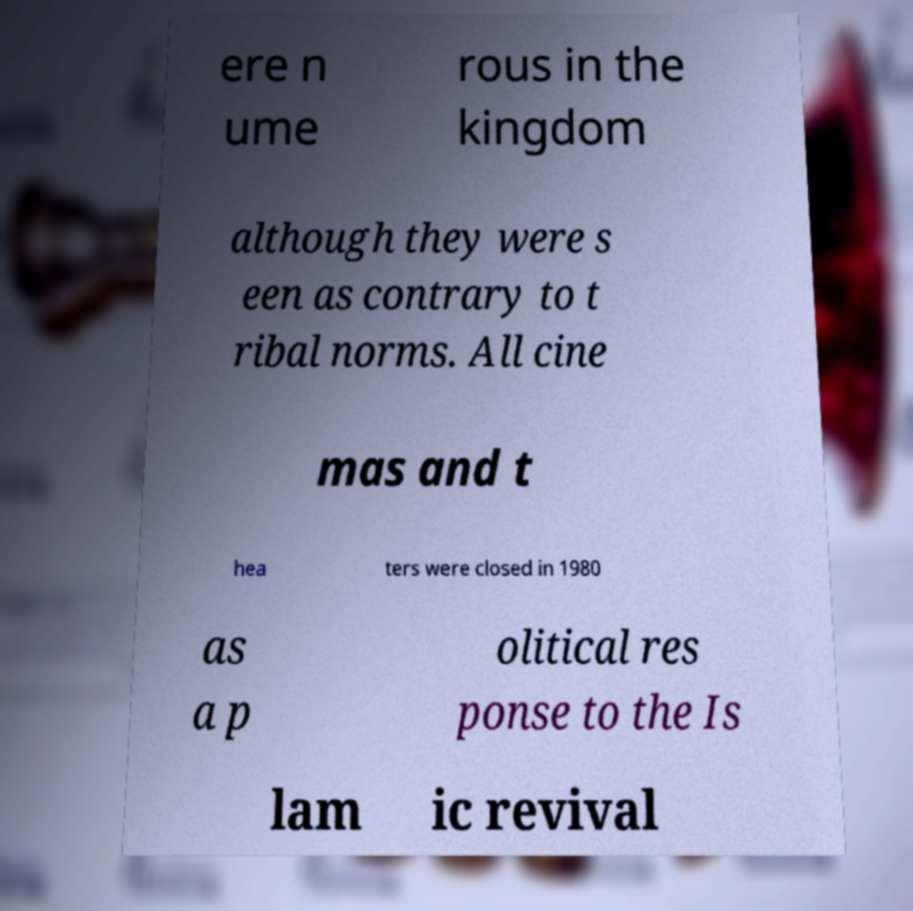Can you accurately transcribe the text from the provided image for me? ere n ume rous in the kingdom although they were s een as contrary to t ribal norms. All cine mas and t hea ters were closed in 1980 as a p olitical res ponse to the Is lam ic revival 